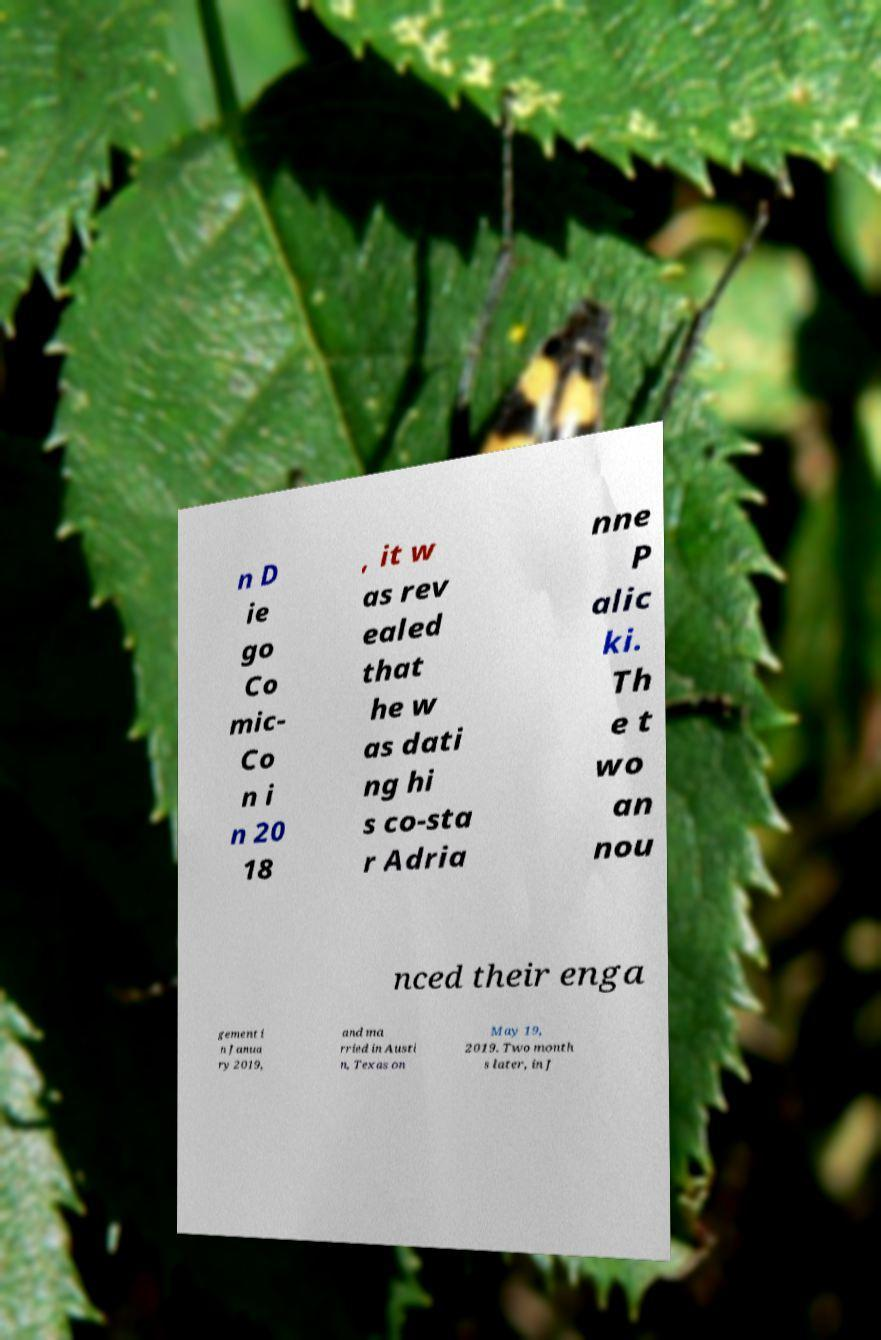Can you read and provide the text displayed in the image?This photo seems to have some interesting text. Can you extract and type it out for me? n D ie go Co mic- Co n i n 20 18 , it w as rev ealed that he w as dati ng hi s co-sta r Adria nne P alic ki. Th e t wo an nou nced their enga gement i n Janua ry 2019, and ma rried in Austi n, Texas on May 19, 2019. Two month s later, in J 